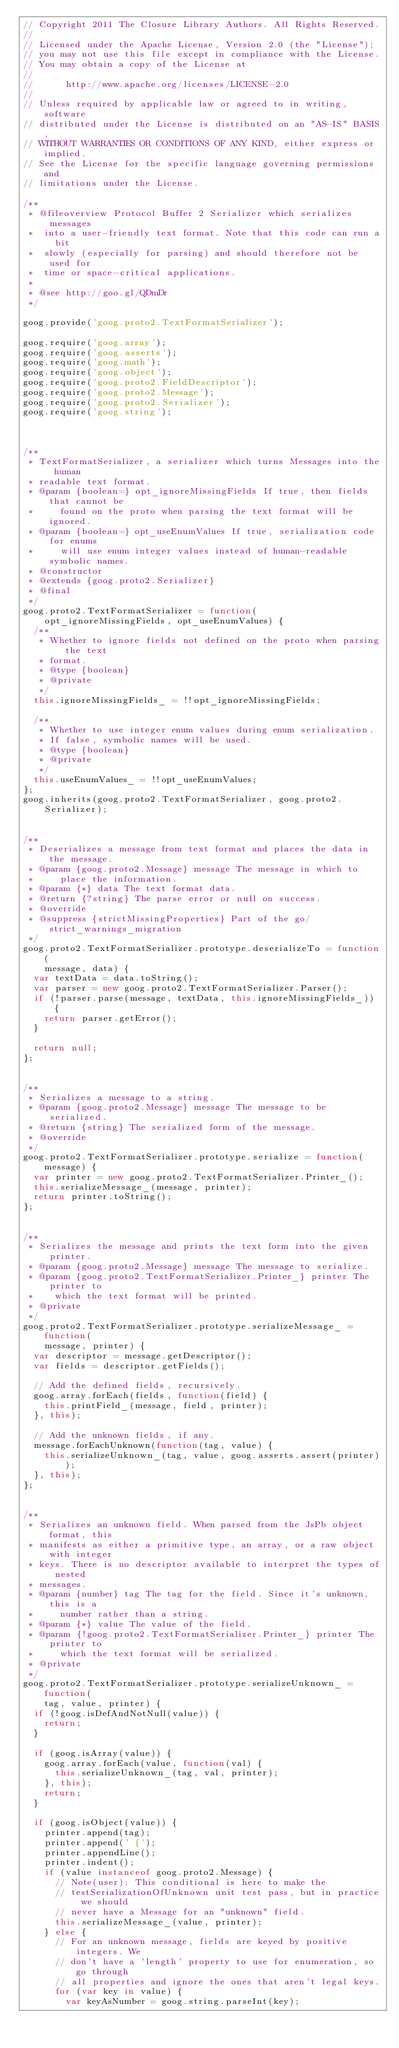Convert code to text. <code><loc_0><loc_0><loc_500><loc_500><_JavaScript_>// Copyright 2011 The Closure Library Authors. All Rights Reserved.
//
// Licensed under the Apache License, Version 2.0 (the "License");
// you may not use this file except in compliance with the License.
// You may obtain a copy of the License at
//
//      http://www.apache.org/licenses/LICENSE-2.0
//
// Unless required by applicable law or agreed to in writing, software
// distributed under the License is distributed on an "AS-IS" BASIS,
// WITHOUT WARRANTIES OR CONDITIONS OF ANY KIND, either express or implied.
// See the License for the specific language governing permissions and
// limitations under the License.

/**
 * @fileoverview Protocol Buffer 2 Serializer which serializes messages
 *  into a user-friendly text format. Note that this code can run a bit
 *  slowly (especially for parsing) and should therefore not be used for
 *  time or space-critical applications.
 *
 * @see http://goo.gl/QDmDr
 */

goog.provide('goog.proto2.TextFormatSerializer');

goog.require('goog.array');
goog.require('goog.asserts');
goog.require('goog.math');
goog.require('goog.object');
goog.require('goog.proto2.FieldDescriptor');
goog.require('goog.proto2.Message');
goog.require('goog.proto2.Serializer');
goog.require('goog.string');



/**
 * TextFormatSerializer, a serializer which turns Messages into the human
 * readable text format.
 * @param {boolean=} opt_ignoreMissingFields If true, then fields that cannot be
 *     found on the proto when parsing the text format will be ignored.
 * @param {boolean=} opt_useEnumValues If true, serialization code for enums
 *     will use enum integer values instead of human-readable symbolic names.
 * @constructor
 * @extends {goog.proto2.Serializer}
 * @final
 */
goog.proto2.TextFormatSerializer = function(
    opt_ignoreMissingFields, opt_useEnumValues) {
  /**
   * Whether to ignore fields not defined on the proto when parsing the text
   * format.
   * @type {boolean}
   * @private
   */
  this.ignoreMissingFields_ = !!opt_ignoreMissingFields;

  /**
   * Whether to use integer enum values during enum serialization.
   * If false, symbolic names will be used.
   * @type {boolean}
   * @private
   */
  this.useEnumValues_ = !!opt_useEnumValues;
};
goog.inherits(goog.proto2.TextFormatSerializer, goog.proto2.Serializer);


/**
 * Deserializes a message from text format and places the data in the message.
 * @param {goog.proto2.Message} message The message in which to
 *     place the information.
 * @param {*} data The text format data.
 * @return {?string} The parse error or null on success.
 * @override
 * @suppress {strictMissingProperties} Part of the go/strict_warnings_migration
 */
goog.proto2.TextFormatSerializer.prototype.deserializeTo = function(
    message, data) {
  var textData = data.toString();
  var parser = new goog.proto2.TextFormatSerializer.Parser();
  if (!parser.parse(message, textData, this.ignoreMissingFields_)) {
    return parser.getError();
  }

  return null;
};


/**
 * Serializes a message to a string.
 * @param {goog.proto2.Message} message The message to be serialized.
 * @return {string} The serialized form of the message.
 * @override
 */
goog.proto2.TextFormatSerializer.prototype.serialize = function(message) {
  var printer = new goog.proto2.TextFormatSerializer.Printer_();
  this.serializeMessage_(message, printer);
  return printer.toString();
};


/**
 * Serializes the message and prints the text form into the given printer.
 * @param {goog.proto2.Message} message The message to serialize.
 * @param {goog.proto2.TextFormatSerializer.Printer_} printer The printer to
 *    which the text format will be printed.
 * @private
 */
goog.proto2.TextFormatSerializer.prototype.serializeMessage_ = function(
    message, printer) {
  var descriptor = message.getDescriptor();
  var fields = descriptor.getFields();

  // Add the defined fields, recursively.
  goog.array.forEach(fields, function(field) {
    this.printField_(message, field, printer);
  }, this);

  // Add the unknown fields, if any.
  message.forEachUnknown(function(tag, value) {
    this.serializeUnknown_(tag, value, goog.asserts.assert(printer));
  }, this);
};


/**
 * Serializes an unknown field. When parsed from the JsPb object format, this
 * manifests as either a primitive type, an array, or a raw object with integer
 * keys. There is no descriptor available to interpret the types of nested
 * messages.
 * @param {number} tag The tag for the field. Since it's unknown, this is a
 *     number rather than a string.
 * @param {*} value The value of the field.
 * @param {!goog.proto2.TextFormatSerializer.Printer_} printer The printer to
 *     which the text format will be serialized.
 * @private
 */
goog.proto2.TextFormatSerializer.prototype.serializeUnknown_ = function(
    tag, value, printer) {
  if (!goog.isDefAndNotNull(value)) {
    return;
  }

  if (goog.isArray(value)) {
    goog.array.forEach(value, function(val) {
      this.serializeUnknown_(tag, val, printer);
    }, this);
    return;
  }

  if (goog.isObject(value)) {
    printer.append(tag);
    printer.append(' {');
    printer.appendLine();
    printer.indent();
    if (value instanceof goog.proto2.Message) {
      // Note(user): This conditional is here to make the
      // testSerializationOfUnknown unit test pass, but in practice we should
      // never have a Message for an "unknown" field.
      this.serializeMessage_(value, printer);
    } else {
      // For an unknown message, fields are keyed by positive integers. We
      // don't have a 'length' property to use for enumeration, so go through
      // all properties and ignore the ones that aren't legal keys.
      for (var key in value) {
        var keyAsNumber = goog.string.parseInt(key);</code> 